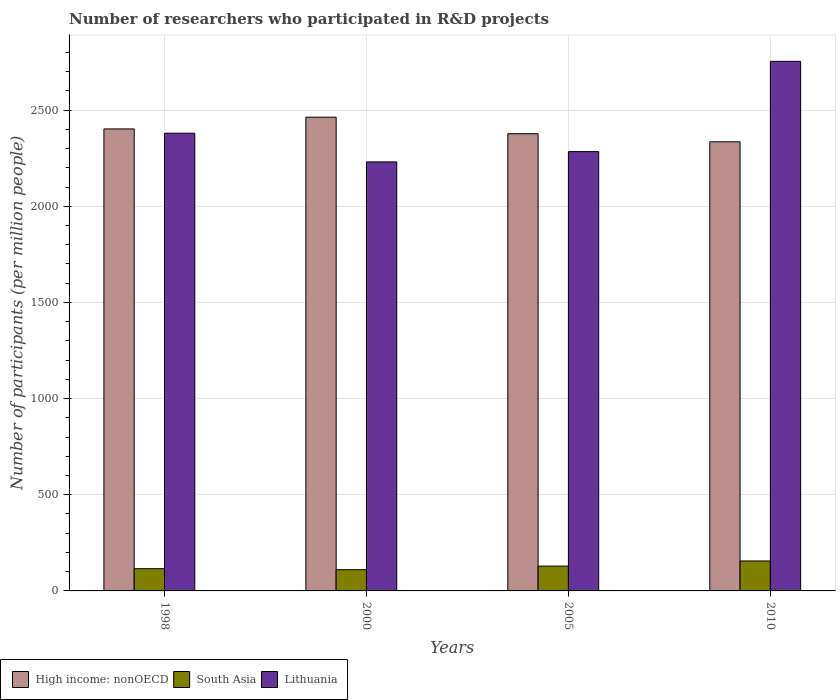How many different coloured bars are there?
Make the answer very short. 3. How many bars are there on the 1st tick from the left?
Offer a terse response. 3. How many bars are there on the 4th tick from the right?
Provide a succinct answer. 3. In how many cases, is the number of bars for a given year not equal to the number of legend labels?
Make the answer very short. 0. What is the number of researchers who participated in R&D projects in South Asia in 2000?
Offer a terse response. 110.5. Across all years, what is the maximum number of researchers who participated in R&D projects in Lithuania?
Offer a terse response. 2753.59. Across all years, what is the minimum number of researchers who participated in R&D projects in South Asia?
Provide a short and direct response. 110.5. What is the total number of researchers who participated in R&D projects in South Asia in the graph?
Your response must be concise. 511.02. What is the difference between the number of researchers who participated in R&D projects in South Asia in 1998 and that in 2010?
Ensure brevity in your answer.  -40.17. What is the difference between the number of researchers who participated in R&D projects in Lithuania in 2000 and the number of researchers who participated in R&D projects in South Asia in 1998?
Give a very brief answer. 2115.05. What is the average number of researchers who participated in R&D projects in South Asia per year?
Ensure brevity in your answer.  127.75. In the year 2010, what is the difference between the number of researchers who participated in R&D projects in Lithuania and number of researchers who participated in R&D projects in High income: nonOECD?
Provide a succinct answer. 418.23. In how many years, is the number of researchers who participated in R&D projects in South Asia greater than 200?
Your answer should be very brief. 0. What is the ratio of the number of researchers who participated in R&D projects in High income: nonOECD in 1998 to that in 2000?
Make the answer very short. 0.98. Is the number of researchers who participated in R&D projects in High income: nonOECD in 1998 less than that in 2000?
Give a very brief answer. Yes. Is the difference between the number of researchers who participated in R&D projects in Lithuania in 1998 and 2000 greater than the difference between the number of researchers who participated in R&D projects in High income: nonOECD in 1998 and 2000?
Your answer should be compact. Yes. What is the difference between the highest and the second highest number of researchers who participated in R&D projects in South Asia?
Offer a terse response. 26.71. What is the difference between the highest and the lowest number of researchers who participated in R&D projects in South Asia?
Provide a succinct answer. 45.31. Is the sum of the number of researchers who participated in R&D projects in High income: nonOECD in 2000 and 2005 greater than the maximum number of researchers who participated in R&D projects in South Asia across all years?
Your response must be concise. Yes. What does the 3rd bar from the right in 1998 represents?
Your answer should be very brief. High income: nonOECD. Are the values on the major ticks of Y-axis written in scientific E-notation?
Your answer should be very brief. No. Does the graph contain any zero values?
Make the answer very short. No. Does the graph contain grids?
Give a very brief answer. Yes. How many legend labels are there?
Give a very brief answer. 3. How are the legend labels stacked?
Your answer should be compact. Horizontal. What is the title of the graph?
Offer a very short reply. Number of researchers who participated in R&D projects. Does "Curacao" appear as one of the legend labels in the graph?
Your response must be concise. No. What is the label or title of the Y-axis?
Give a very brief answer. Number of participants (per million people). What is the Number of participants (per million people) of High income: nonOECD in 1998?
Offer a terse response. 2402.25. What is the Number of participants (per million people) of South Asia in 1998?
Provide a short and direct response. 115.63. What is the Number of participants (per million people) in Lithuania in 1998?
Your answer should be very brief. 2379.91. What is the Number of participants (per million people) of High income: nonOECD in 2000?
Give a very brief answer. 2463.22. What is the Number of participants (per million people) of South Asia in 2000?
Make the answer very short. 110.5. What is the Number of participants (per million people) in Lithuania in 2000?
Offer a terse response. 2230.69. What is the Number of participants (per million people) of High income: nonOECD in 2005?
Ensure brevity in your answer.  2377.3. What is the Number of participants (per million people) in South Asia in 2005?
Keep it short and to the point. 129.09. What is the Number of participants (per million people) of Lithuania in 2005?
Give a very brief answer. 2284.29. What is the Number of participants (per million people) of High income: nonOECD in 2010?
Your answer should be compact. 2335.35. What is the Number of participants (per million people) in South Asia in 2010?
Keep it short and to the point. 155.8. What is the Number of participants (per million people) in Lithuania in 2010?
Your response must be concise. 2753.59. Across all years, what is the maximum Number of participants (per million people) of High income: nonOECD?
Give a very brief answer. 2463.22. Across all years, what is the maximum Number of participants (per million people) in South Asia?
Offer a very short reply. 155.8. Across all years, what is the maximum Number of participants (per million people) of Lithuania?
Ensure brevity in your answer.  2753.59. Across all years, what is the minimum Number of participants (per million people) in High income: nonOECD?
Offer a terse response. 2335.35. Across all years, what is the minimum Number of participants (per million people) in South Asia?
Give a very brief answer. 110.5. Across all years, what is the minimum Number of participants (per million people) in Lithuania?
Offer a very short reply. 2230.69. What is the total Number of participants (per million people) of High income: nonOECD in the graph?
Make the answer very short. 9578.12. What is the total Number of participants (per million people) of South Asia in the graph?
Offer a terse response. 511.02. What is the total Number of participants (per million people) in Lithuania in the graph?
Make the answer very short. 9648.48. What is the difference between the Number of participants (per million people) of High income: nonOECD in 1998 and that in 2000?
Your answer should be compact. -60.98. What is the difference between the Number of participants (per million people) of South Asia in 1998 and that in 2000?
Ensure brevity in your answer.  5.14. What is the difference between the Number of participants (per million people) in Lithuania in 1998 and that in 2000?
Ensure brevity in your answer.  149.23. What is the difference between the Number of participants (per million people) of High income: nonOECD in 1998 and that in 2005?
Ensure brevity in your answer.  24.95. What is the difference between the Number of participants (per million people) of South Asia in 1998 and that in 2005?
Make the answer very short. -13.46. What is the difference between the Number of participants (per million people) in Lithuania in 1998 and that in 2005?
Provide a short and direct response. 95.62. What is the difference between the Number of participants (per million people) in High income: nonOECD in 1998 and that in 2010?
Provide a short and direct response. 66.89. What is the difference between the Number of participants (per million people) of South Asia in 1998 and that in 2010?
Provide a short and direct response. -40.17. What is the difference between the Number of participants (per million people) of Lithuania in 1998 and that in 2010?
Offer a very short reply. -373.68. What is the difference between the Number of participants (per million people) in High income: nonOECD in 2000 and that in 2005?
Your answer should be very brief. 85.93. What is the difference between the Number of participants (per million people) in South Asia in 2000 and that in 2005?
Provide a succinct answer. -18.59. What is the difference between the Number of participants (per million people) in Lithuania in 2000 and that in 2005?
Your answer should be compact. -53.61. What is the difference between the Number of participants (per million people) of High income: nonOECD in 2000 and that in 2010?
Your response must be concise. 127.87. What is the difference between the Number of participants (per million people) of South Asia in 2000 and that in 2010?
Keep it short and to the point. -45.31. What is the difference between the Number of participants (per million people) in Lithuania in 2000 and that in 2010?
Provide a short and direct response. -522.9. What is the difference between the Number of participants (per million people) of High income: nonOECD in 2005 and that in 2010?
Your answer should be compact. 41.94. What is the difference between the Number of participants (per million people) in South Asia in 2005 and that in 2010?
Offer a terse response. -26.71. What is the difference between the Number of participants (per million people) in Lithuania in 2005 and that in 2010?
Ensure brevity in your answer.  -469.3. What is the difference between the Number of participants (per million people) in High income: nonOECD in 1998 and the Number of participants (per million people) in South Asia in 2000?
Make the answer very short. 2291.75. What is the difference between the Number of participants (per million people) of High income: nonOECD in 1998 and the Number of participants (per million people) of Lithuania in 2000?
Give a very brief answer. 171.56. What is the difference between the Number of participants (per million people) in South Asia in 1998 and the Number of participants (per million people) in Lithuania in 2000?
Keep it short and to the point. -2115.05. What is the difference between the Number of participants (per million people) in High income: nonOECD in 1998 and the Number of participants (per million people) in South Asia in 2005?
Provide a succinct answer. 2273.16. What is the difference between the Number of participants (per million people) of High income: nonOECD in 1998 and the Number of participants (per million people) of Lithuania in 2005?
Keep it short and to the point. 117.95. What is the difference between the Number of participants (per million people) of South Asia in 1998 and the Number of participants (per million people) of Lithuania in 2005?
Give a very brief answer. -2168.66. What is the difference between the Number of participants (per million people) in High income: nonOECD in 1998 and the Number of participants (per million people) in South Asia in 2010?
Keep it short and to the point. 2246.44. What is the difference between the Number of participants (per million people) in High income: nonOECD in 1998 and the Number of participants (per million people) in Lithuania in 2010?
Give a very brief answer. -351.34. What is the difference between the Number of participants (per million people) of South Asia in 1998 and the Number of participants (per million people) of Lithuania in 2010?
Your answer should be very brief. -2637.96. What is the difference between the Number of participants (per million people) of High income: nonOECD in 2000 and the Number of participants (per million people) of South Asia in 2005?
Make the answer very short. 2334.14. What is the difference between the Number of participants (per million people) of High income: nonOECD in 2000 and the Number of participants (per million people) of Lithuania in 2005?
Offer a very short reply. 178.93. What is the difference between the Number of participants (per million people) in South Asia in 2000 and the Number of participants (per million people) in Lithuania in 2005?
Your answer should be compact. -2173.8. What is the difference between the Number of participants (per million people) of High income: nonOECD in 2000 and the Number of participants (per million people) of South Asia in 2010?
Your response must be concise. 2307.42. What is the difference between the Number of participants (per million people) in High income: nonOECD in 2000 and the Number of participants (per million people) in Lithuania in 2010?
Your answer should be compact. -290.36. What is the difference between the Number of participants (per million people) in South Asia in 2000 and the Number of participants (per million people) in Lithuania in 2010?
Offer a very short reply. -2643.09. What is the difference between the Number of participants (per million people) in High income: nonOECD in 2005 and the Number of participants (per million people) in South Asia in 2010?
Provide a short and direct response. 2221.5. What is the difference between the Number of participants (per million people) in High income: nonOECD in 2005 and the Number of participants (per million people) in Lithuania in 2010?
Your answer should be compact. -376.29. What is the difference between the Number of participants (per million people) in South Asia in 2005 and the Number of participants (per million people) in Lithuania in 2010?
Make the answer very short. -2624.5. What is the average Number of participants (per million people) in High income: nonOECD per year?
Your answer should be compact. 2394.53. What is the average Number of participants (per million people) of South Asia per year?
Your response must be concise. 127.75. What is the average Number of participants (per million people) of Lithuania per year?
Your response must be concise. 2412.12. In the year 1998, what is the difference between the Number of participants (per million people) of High income: nonOECD and Number of participants (per million people) of South Asia?
Make the answer very short. 2286.61. In the year 1998, what is the difference between the Number of participants (per million people) of High income: nonOECD and Number of participants (per million people) of Lithuania?
Offer a very short reply. 22.33. In the year 1998, what is the difference between the Number of participants (per million people) in South Asia and Number of participants (per million people) in Lithuania?
Offer a very short reply. -2264.28. In the year 2000, what is the difference between the Number of participants (per million people) of High income: nonOECD and Number of participants (per million people) of South Asia?
Your response must be concise. 2352.73. In the year 2000, what is the difference between the Number of participants (per million people) in High income: nonOECD and Number of participants (per million people) in Lithuania?
Your answer should be compact. 232.54. In the year 2000, what is the difference between the Number of participants (per million people) in South Asia and Number of participants (per million people) in Lithuania?
Provide a succinct answer. -2120.19. In the year 2005, what is the difference between the Number of participants (per million people) of High income: nonOECD and Number of participants (per million people) of South Asia?
Provide a succinct answer. 2248.21. In the year 2005, what is the difference between the Number of participants (per million people) in High income: nonOECD and Number of participants (per million people) in Lithuania?
Ensure brevity in your answer.  93.01. In the year 2005, what is the difference between the Number of participants (per million people) in South Asia and Number of participants (per million people) in Lithuania?
Give a very brief answer. -2155.2. In the year 2010, what is the difference between the Number of participants (per million people) of High income: nonOECD and Number of participants (per million people) of South Asia?
Give a very brief answer. 2179.55. In the year 2010, what is the difference between the Number of participants (per million people) in High income: nonOECD and Number of participants (per million people) in Lithuania?
Make the answer very short. -418.23. In the year 2010, what is the difference between the Number of participants (per million people) of South Asia and Number of participants (per million people) of Lithuania?
Provide a succinct answer. -2597.79. What is the ratio of the Number of participants (per million people) of High income: nonOECD in 1998 to that in 2000?
Offer a very short reply. 0.98. What is the ratio of the Number of participants (per million people) in South Asia in 1998 to that in 2000?
Make the answer very short. 1.05. What is the ratio of the Number of participants (per million people) in Lithuania in 1998 to that in 2000?
Offer a terse response. 1.07. What is the ratio of the Number of participants (per million people) in High income: nonOECD in 1998 to that in 2005?
Your response must be concise. 1.01. What is the ratio of the Number of participants (per million people) in South Asia in 1998 to that in 2005?
Your response must be concise. 0.9. What is the ratio of the Number of participants (per million people) in Lithuania in 1998 to that in 2005?
Provide a short and direct response. 1.04. What is the ratio of the Number of participants (per million people) of High income: nonOECD in 1998 to that in 2010?
Your response must be concise. 1.03. What is the ratio of the Number of participants (per million people) in South Asia in 1998 to that in 2010?
Offer a very short reply. 0.74. What is the ratio of the Number of participants (per million people) of Lithuania in 1998 to that in 2010?
Ensure brevity in your answer.  0.86. What is the ratio of the Number of participants (per million people) in High income: nonOECD in 2000 to that in 2005?
Your answer should be compact. 1.04. What is the ratio of the Number of participants (per million people) in South Asia in 2000 to that in 2005?
Keep it short and to the point. 0.86. What is the ratio of the Number of participants (per million people) of Lithuania in 2000 to that in 2005?
Offer a very short reply. 0.98. What is the ratio of the Number of participants (per million people) in High income: nonOECD in 2000 to that in 2010?
Ensure brevity in your answer.  1.05. What is the ratio of the Number of participants (per million people) of South Asia in 2000 to that in 2010?
Offer a terse response. 0.71. What is the ratio of the Number of participants (per million people) in Lithuania in 2000 to that in 2010?
Make the answer very short. 0.81. What is the ratio of the Number of participants (per million people) in South Asia in 2005 to that in 2010?
Keep it short and to the point. 0.83. What is the ratio of the Number of participants (per million people) of Lithuania in 2005 to that in 2010?
Your answer should be compact. 0.83. What is the difference between the highest and the second highest Number of participants (per million people) in High income: nonOECD?
Your answer should be compact. 60.98. What is the difference between the highest and the second highest Number of participants (per million people) in South Asia?
Provide a succinct answer. 26.71. What is the difference between the highest and the second highest Number of participants (per million people) of Lithuania?
Provide a short and direct response. 373.68. What is the difference between the highest and the lowest Number of participants (per million people) of High income: nonOECD?
Give a very brief answer. 127.87. What is the difference between the highest and the lowest Number of participants (per million people) of South Asia?
Offer a very short reply. 45.31. What is the difference between the highest and the lowest Number of participants (per million people) of Lithuania?
Provide a short and direct response. 522.9. 